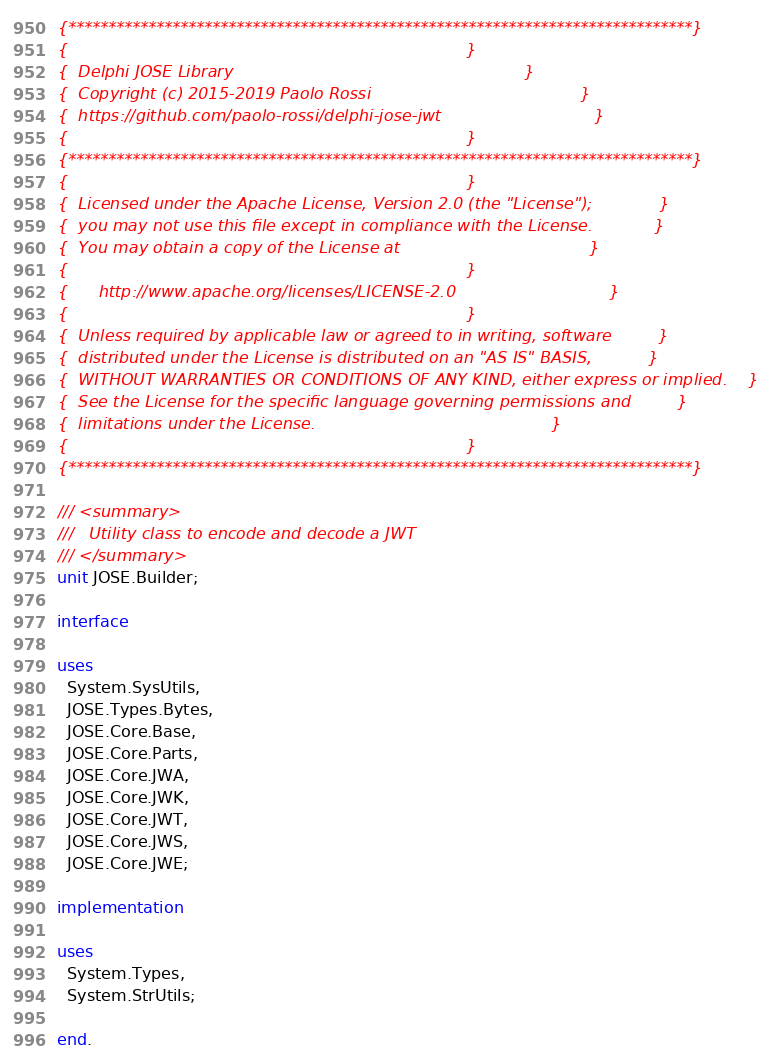Convert code to text. <code><loc_0><loc_0><loc_500><loc_500><_Pascal_>{******************************************************************************}
{                                                                              }
{  Delphi JOSE Library                                                         }
{  Copyright (c) 2015-2019 Paolo Rossi                                         }
{  https://github.com/paolo-rossi/delphi-jose-jwt                              }
{                                                                              }
{******************************************************************************}
{                                                                              }
{  Licensed under the Apache License, Version 2.0 (the "License");             }
{  you may not use this file except in compliance with the License.            }
{  You may obtain a copy of the License at                                     }
{                                                                              }
{      http://www.apache.org/licenses/LICENSE-2.0                              }
{                                                                              }
{  Unless required by applicable law or agreed to in writing, software         }
{  distributed under the License is distributed on an "AS IS" BASIS,           }
{  WITHOUT WARRANTIES OR CONDITIONS OF ANY KIND, either express or implied.    }
{  See the License for the specific language governing permissions and         }
{  limitations under the License.                                              }
{                                                                              }
{******************************************************************************}

/// <summary>
///   Utility class to encode and decode a JWT
/// </summary>
unit JOSE.Builder;

interface

uses
  System.SysUtils,
  JOSE.Types.Bytes,
  JOSE.Core.Base,
  JOSE.Core.Parts,
  JOSE.Core.JWA,
  JOSE.Core.JWK,
  JOSE.Core.JWT,
  JOSE.Core.JWS,
  JOSE.Core.JWE;

implementation

uses
  System.Types,
  System.StrUtils;

end.
</code> 